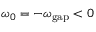Convert formula to latex. <formula><loc_0><loc_0><loc_500><loc_500>\omega _ { 0 } = - \omega _ { g a p } < 0</formula> 